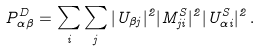Convert formula to latex. <formula><loc_0><loc_0><loc_500><loc_500>P ^ { D } _ { \alpha \beta } = \sum _ { i } \sum _ { j } | U _ { \beta j } | ^ { 2 } | M ^ { S } _ { j i } | ^ { 2 } | U ^ { S } _ { \alpha i } | ^ { 2 } \, .</formula> 